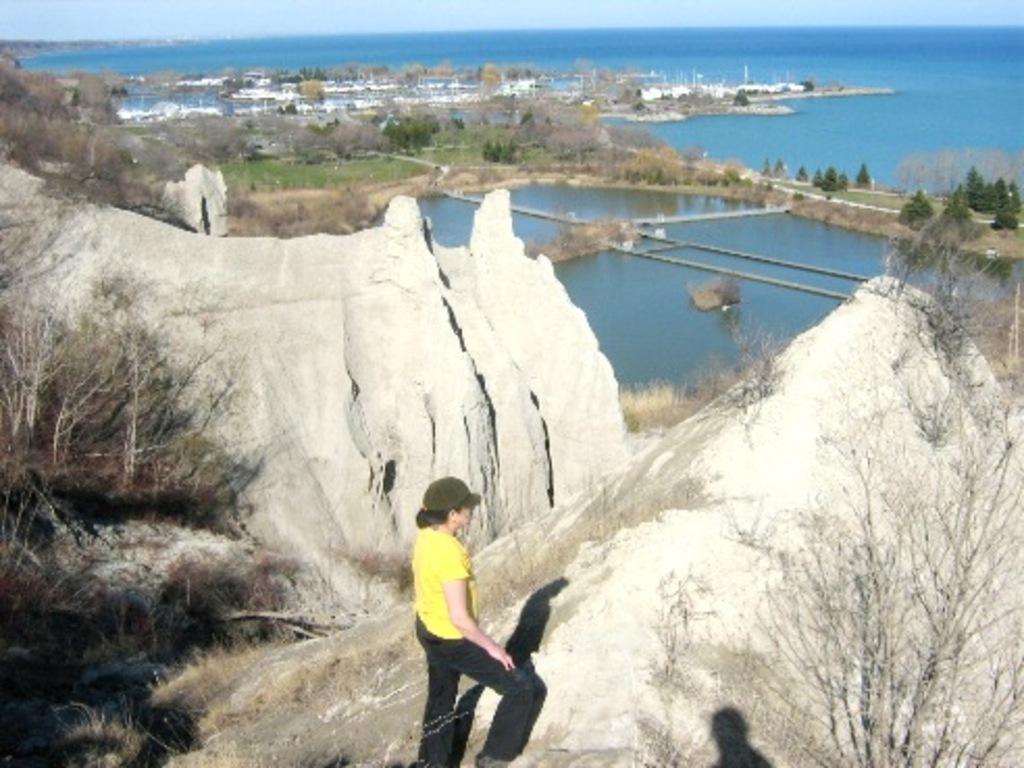How would you summarize this image in a sentence or two? There is a person in yellow color t-shirt walking on the surface of a hill. In the background, there are trees, buildings and grass on the ground, there is a water pond, there is water of an ocean and there is sky. 